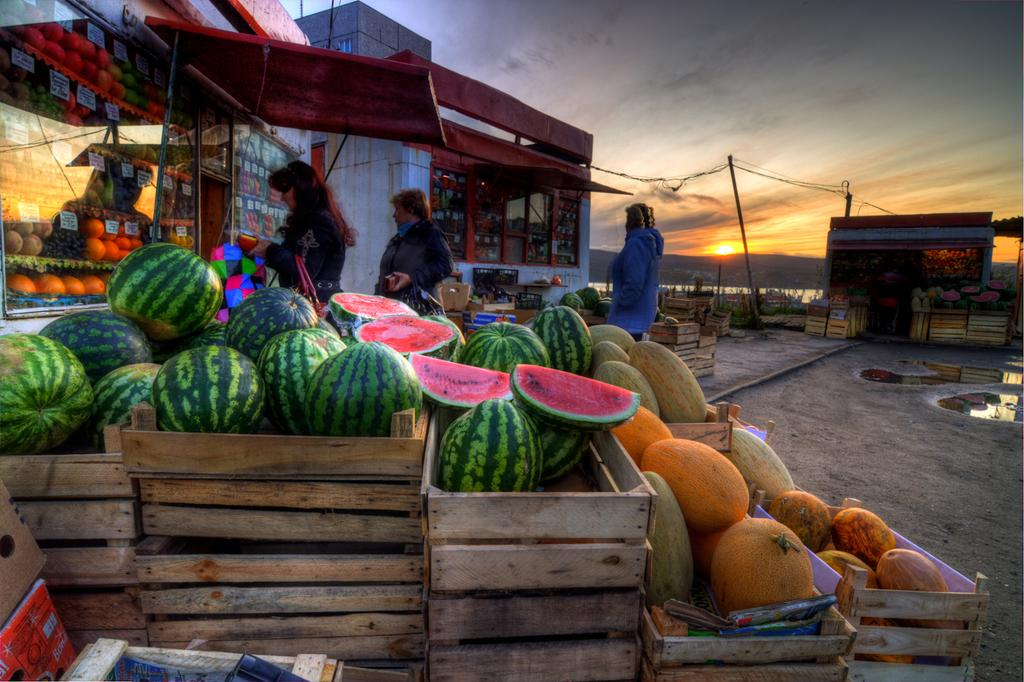What is the main subject in the center of the image? There are fruits in the center of the image. What can be seen on the right side of the image? There are stalls on the right side of the image. What can be seen on the left side of the image? There are stalls on the left side of the image. What else is present in the center of the image besides the fruits? There are people in the center of the image. How much money does the guide regret losing in the image? There is no guide or mention of money in the image; it features fruits, stalls, and people. 